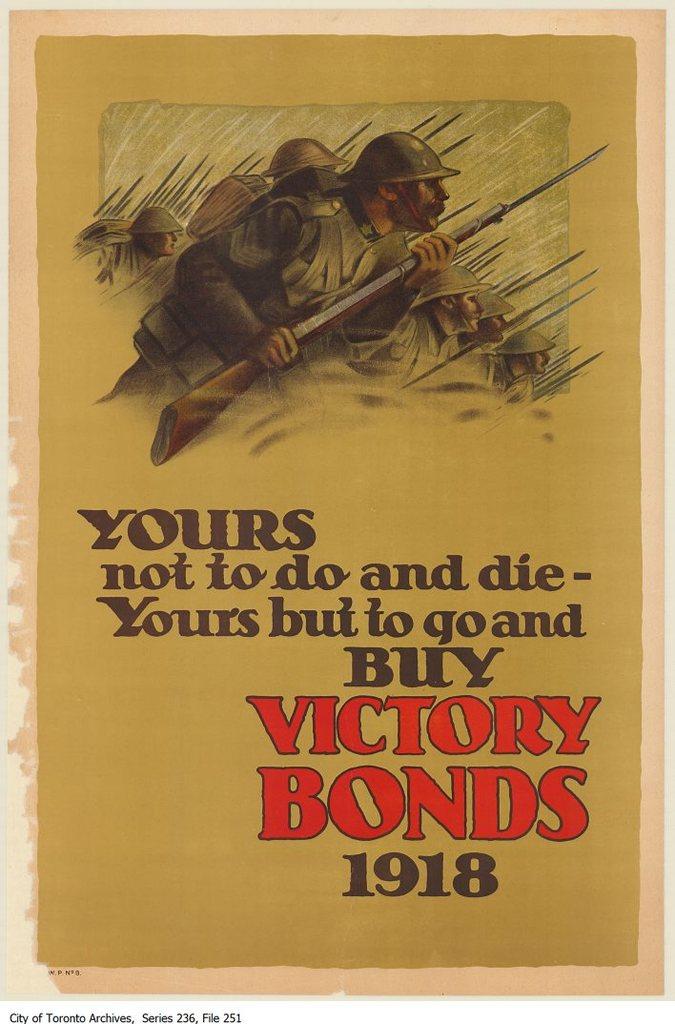What year is this book base on?
Offer a terse response. 1918. When was this flyer produced?
Provide a succinct answer. 1918. 